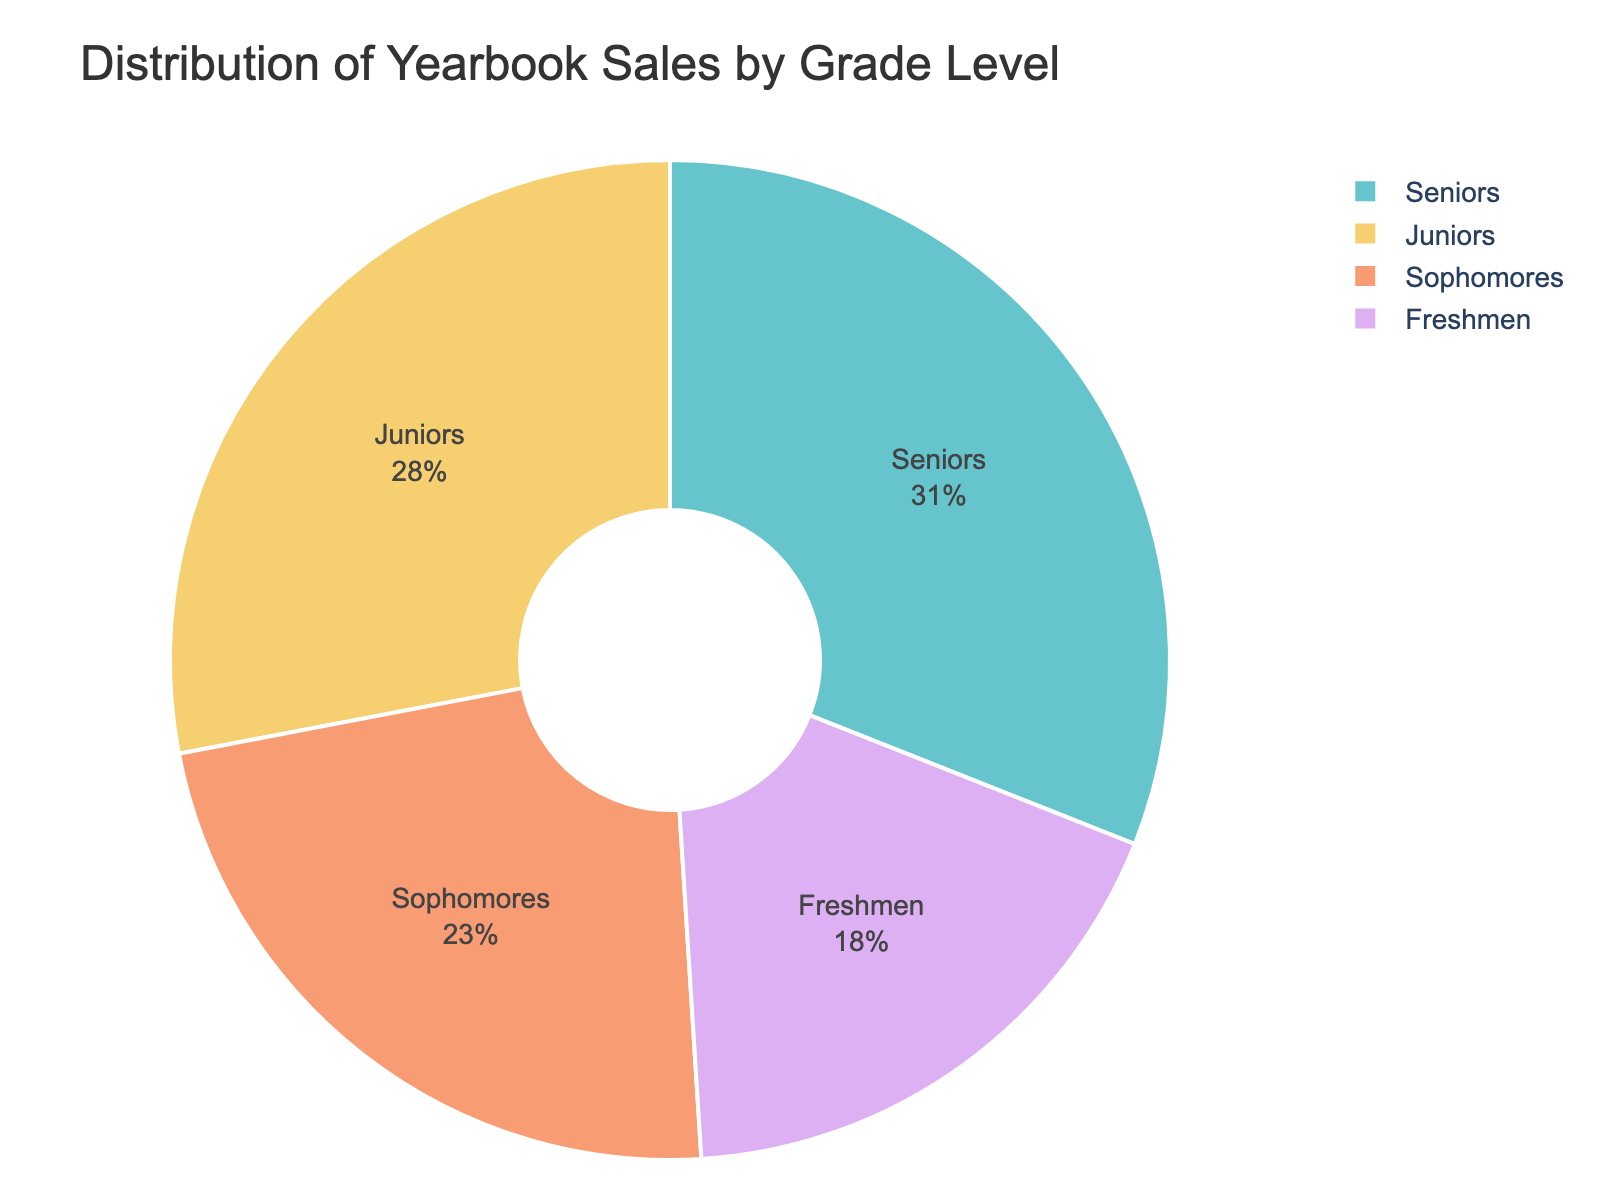What percentage of yearbook sales are from Juniors? The pie chart shows the distribution of yearbook sales by grade level. The segment labeled "Juniors" represents 28% of the total sales.
Answer: 28% Which grade level has the highest percentage of yearbook sales? The pie chart shows that the "Seniors" segment occupies the largest portion of the chart, labeled with a percentage of 31%.
Answer: Seniors How much higher is the yearbook sales percentage for Seniors compared to Freshmen? The Seniors have 31% and the Freshmen have 18%. The difference is 31% - 18% = 13%.
Answer: 13% What is the total percentage of yearbook sales for underclassmen (Freshmen and Sophomores)? The Freshmen occupy 18% and the Sophomores occupy 23%. Adding these together gives 18% + 23% = 41%.
Answer: 41% Which grade level has the second-highest percentage of yearbook sales? The pie chart shows the distribution labeled by grade level. The largest is "Seniors" with 31%, and the second-largest segment is "Juniors" with 28%.
Answer: Juniors How much lower is the yearbook sales percentage for Freshmen compared to Juniors? Juniors have 28%, and Freshmen have 18%. The difference is 28% - 18% = 10%.
Answer: 10% What percentage of yearbook sales comes from upperclassmen (Juniors and Seniors)? Juniors have 28% and Seniors have 31%. Adding these together gives 28% + 31% = 59%.
Answer: 59% Do Sophomores contribute more than a quarter (25%) of the total yearbook sales? The pie chart shows that Sophomores contribute 23% of the total yearbook sales, which is less than 25%.
Answer: No Which grade level contributes the least to yearbook sales? The pie chart shows that the smallest segment is labeled "Freshmen," with a contribution of 18%.
Answer: Freshmen What is the combined percentage of yearbook sales from Sophomores and Juniors? Sophomores contribute 23% and Juniors contribute 28%. Adding these together gives 23% + 28% = 51%.
Answer: 51% 